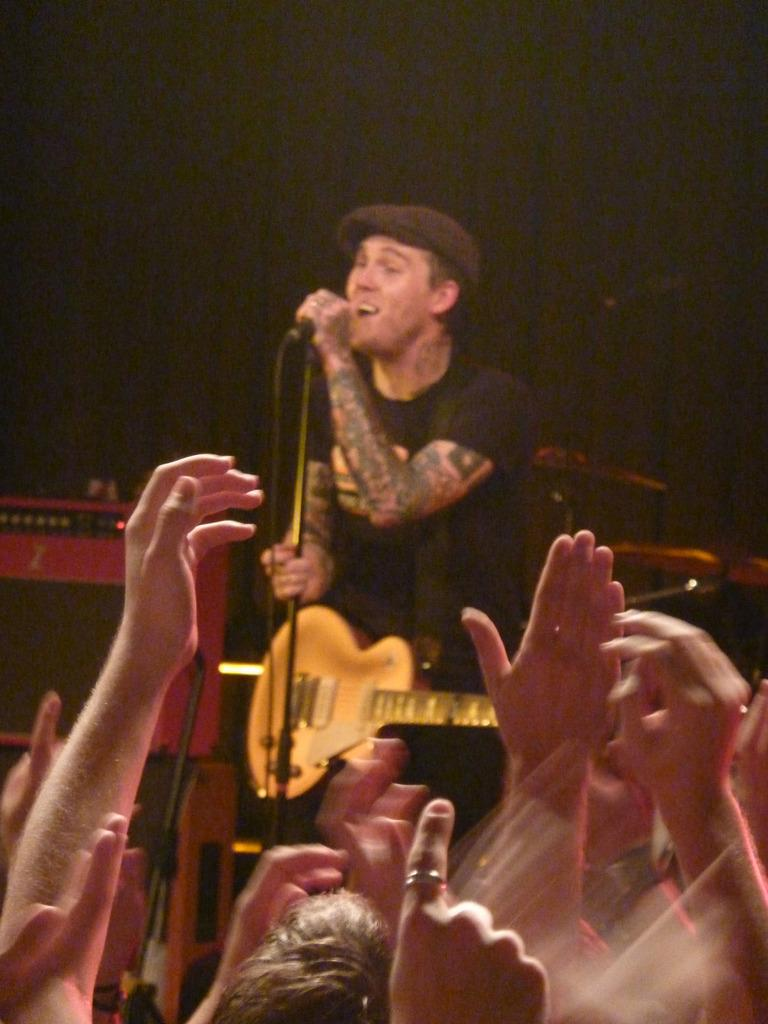What is the main subject of the image? There is a person in the image. What is the person wearing? The person is wearing a guitar. What is the person doing in the image? The person is singing. What object is in front of the person? There is a microphone in front of the person. What can be seen in the hands of the people in front of the person? There are hands raised up in front of the person. How many matches are visible in the image? There are no matches present in the image. What type of trucks can be seen in the background of the image? There are no trucks visible in the image. 